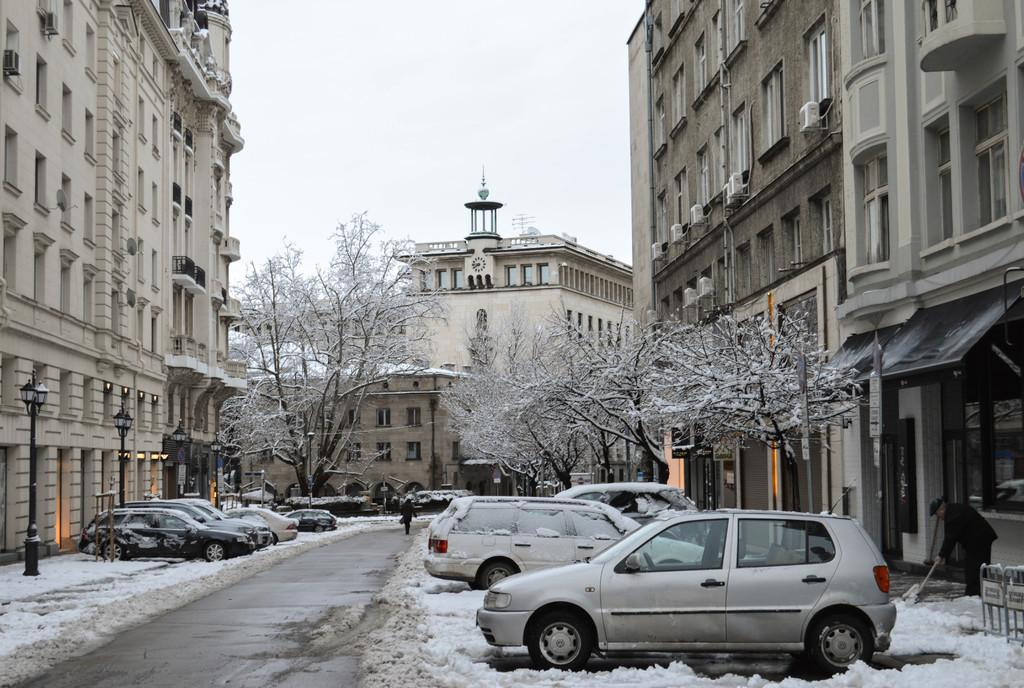What is the surface on which the vehicles are parked in the image? The vehicles are parked on the snow in the image. What type of structures can be seen in the image? There are buildings in the image. Can you describe the people in the image? Two persons are standing in the image. What can be seen illuminating the scene in the image? There are lights visible in the image. What objects are present in the image that might be used for supporting or guiding? There are poles in the image. What type of natural elements are present in the image? Trees are present in the image. What part of the natural environment is visible in the image? The sky is visible in the image. What type of machine is being operated by the wind in the image? There is no machine being operated by the wind in the image. What type of branch is hanging from the trees in the image? There are no branches hanging from the trees in the image; only the trees themselves are present. 